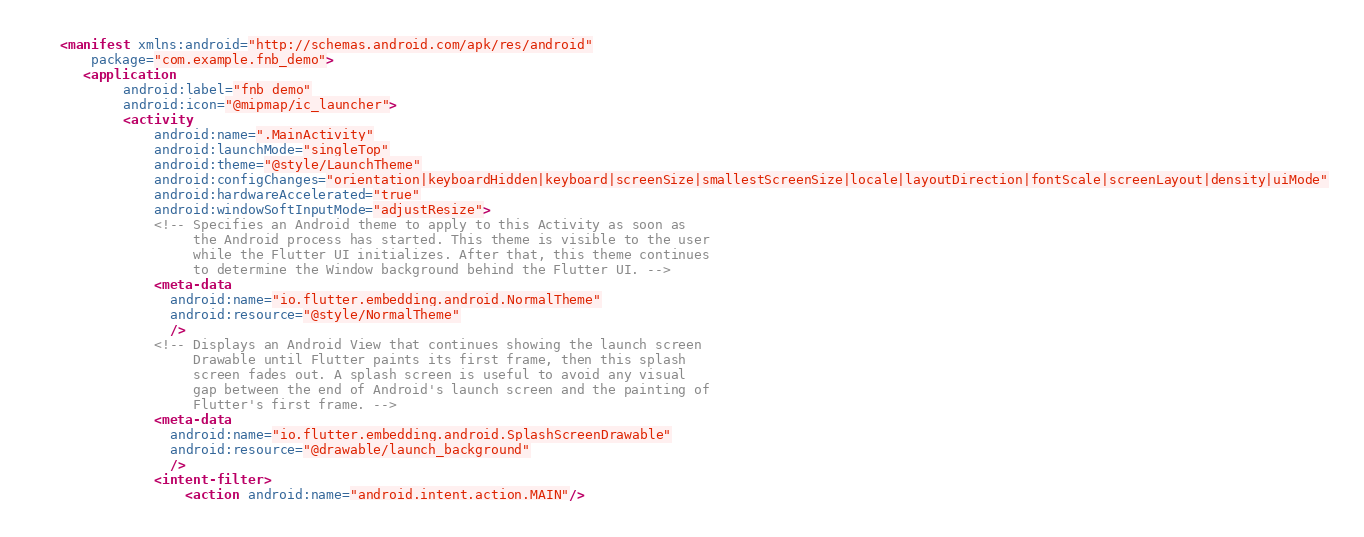Convert code to text. <code><loc_0><loc_0><loc_500><loc_500><_XML_><manifest xmlns:android="http://schemas.android.com/apk/res/android"
    package="com.example.fnb_demo">
   <application
        android:label="fnb_demo"
        android:icon="@mipmap/ic_launcher">
        <activity
            android:name=".MainActivity"
            android:launchMode="singleTop"
            android:theme="@style/LaunchTheme"
            android:configChanges="orientation|keyboardHidden|keyboard|screenSize|smallestScreenSize|locale|layoutDirection|fontScale|screenLayout|density|uiMode"
            android:hardwareAccelerated="true"
            android:windowSoftInputMode="adjustResize">
            <!-- Specifies an Android theme to apply to this Activity as soon as
                 the Android process has started. This theme is visible to the user
                 while the Flutter UI initializes. After that, this theme continues
                 to determine the Window background behind the Flutter UI. -->
            <meta-data
              android:name="io.flutter.embedding.android.NormalTheme"
              android:resource="@style/NormalTheme"
              />
            <!-- Displays an Android View that continues showing the launch screen
                 Drawable until Flutter paints its first frame, then this splash
                 screen fades out. A splash screen is useful to avoid any visual
                 gap between the end of Android's launch screen and the painting of
                 Flutter's first frame. -->
            <meta-data
              android:name="io.flutter.embedding.android.SplashScreenDrawable"
              android:resource="@drawable/launch_background"
              />
            <intent-filter>
                <action android:name="android.intent.action.MAIN"/></code> 